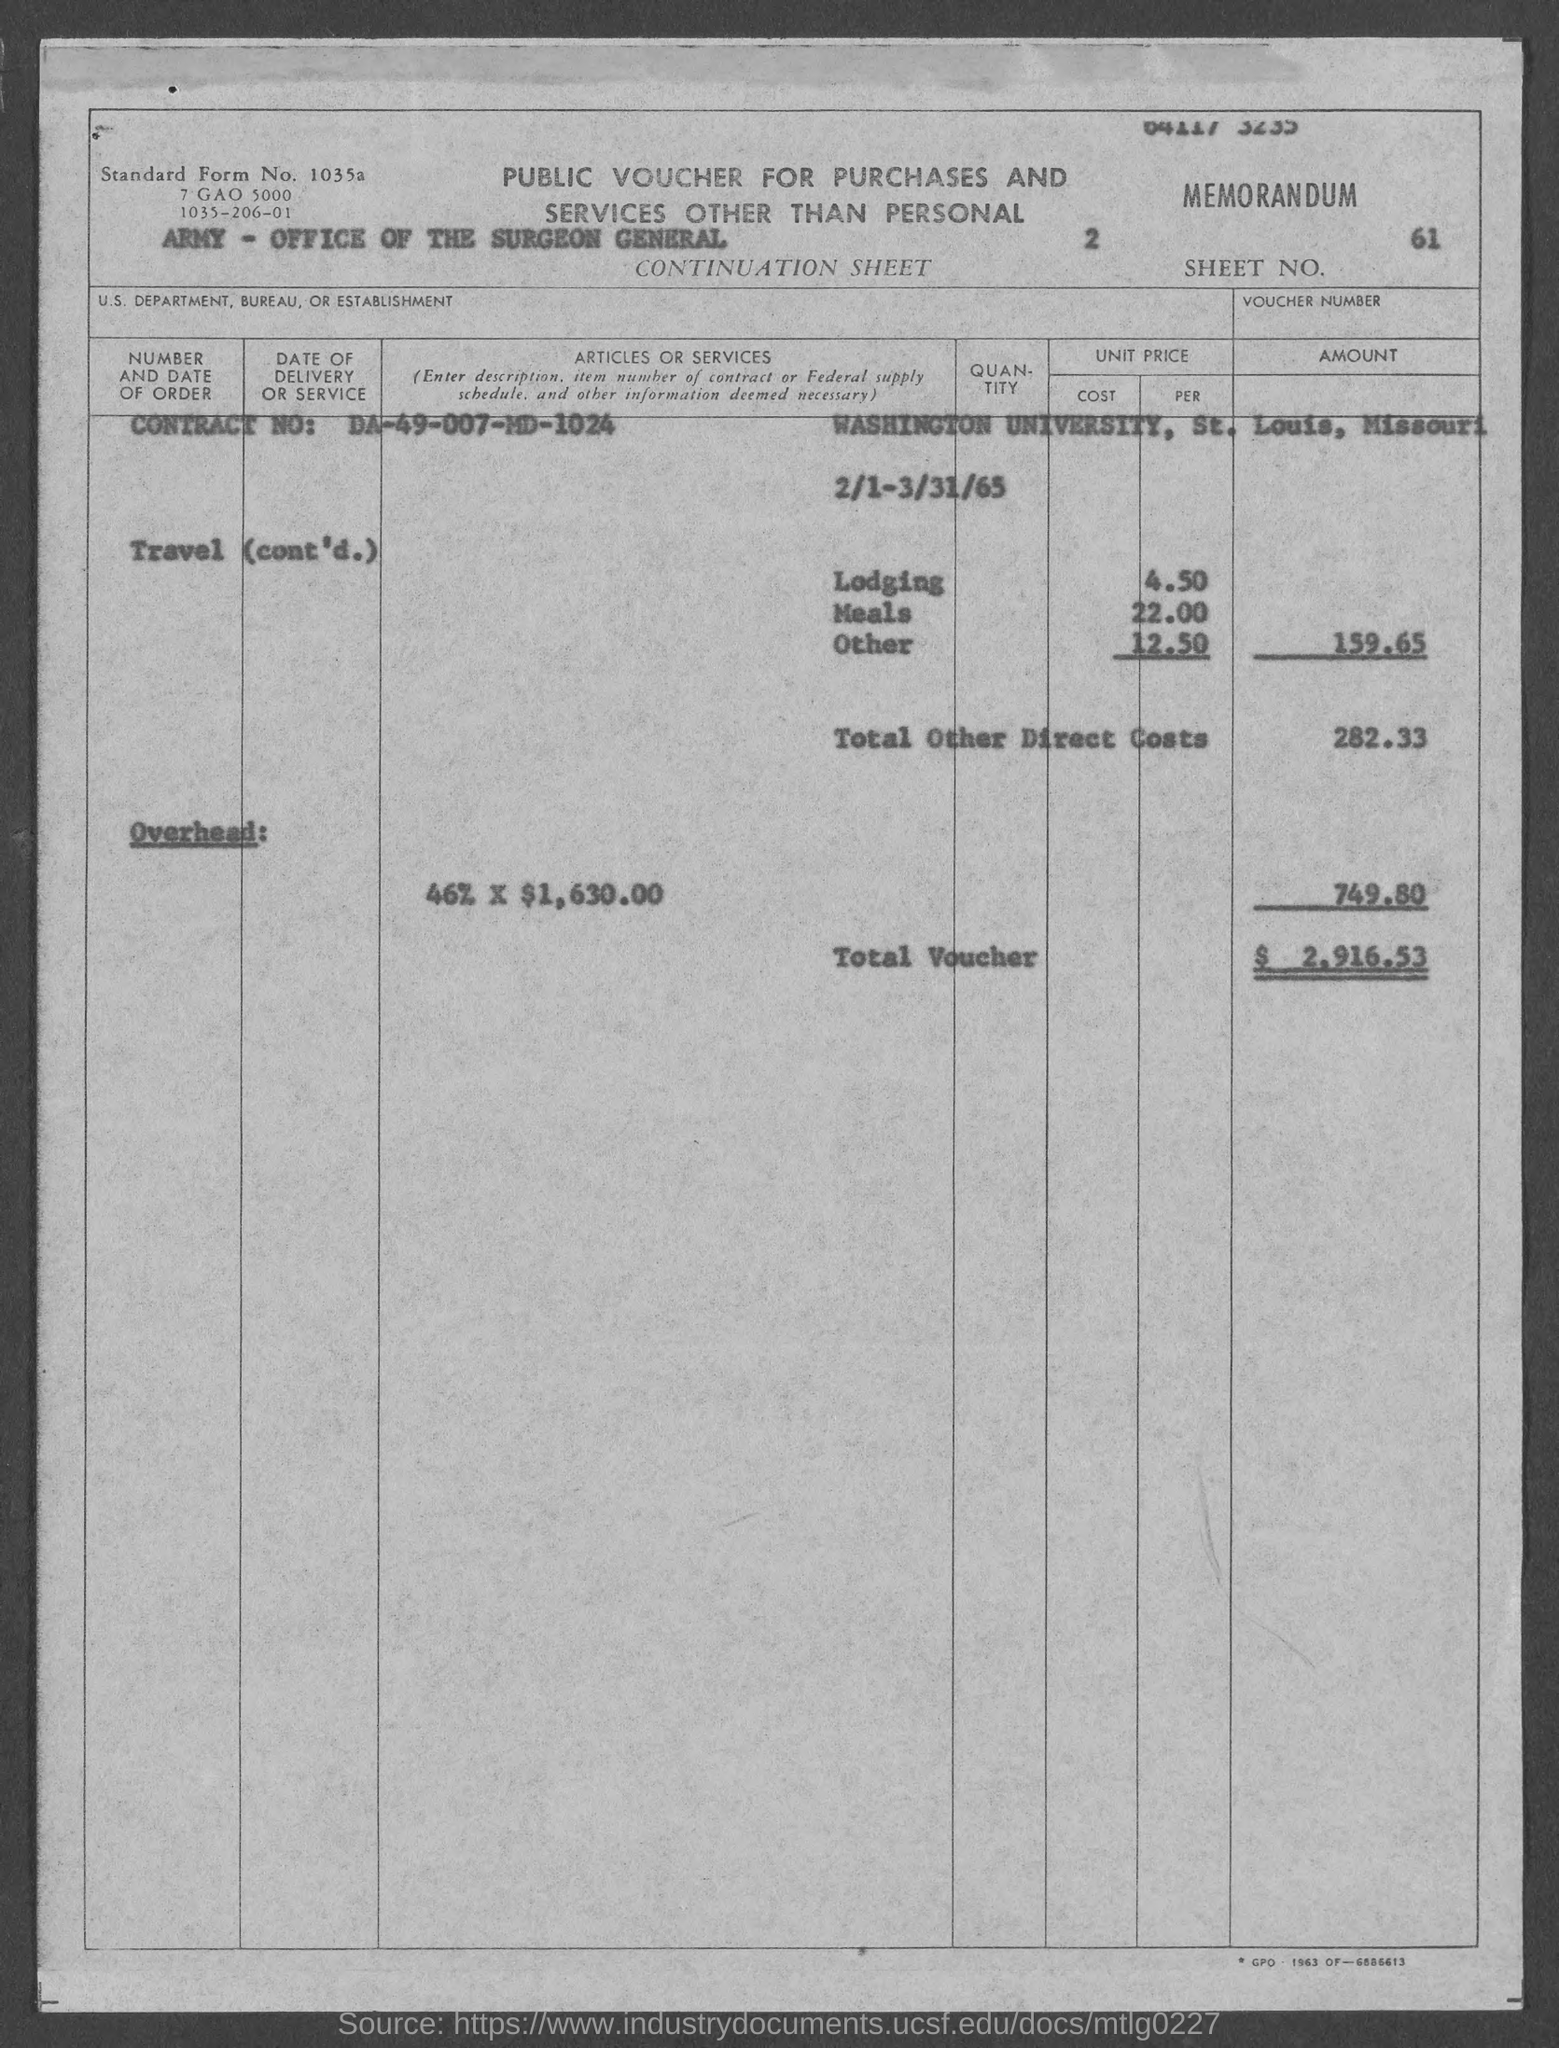What is the Contract No:?
Your answer should be compact. DA-49-007-MD-1024. What is the Total Other Direct Costs?
Offer a very short reply. 282.33. What is the Total Voucher Amount?
Provide a succinct answer. 2,916.53. What is the Sheet No.?
Your response must be concise. 61. 